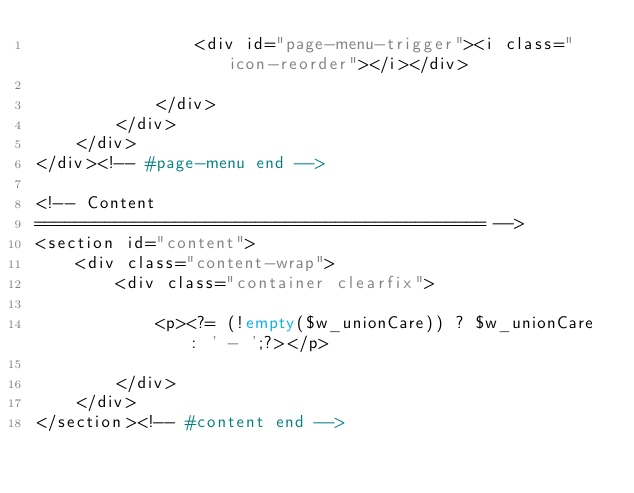Convert code to text. <code><loc_0><loc_0><loc_500><loc_500><_PHP_>                <div id="page-menu-trigger"><i class="icon-reorder"></i></div>

            </div>
        </div>
    </div>
</div><!-- #page-menu end -->

<!-- Content
============================================= -->
<section id="content">
    <div class="content-wrap">
        <div class="container clearfix">

            <p><?= (!empty($w_unionCare)) ? $w_unionCare : ' - ';?></p>

        </div>
    </div>
</section><!-- #content end --></code> 